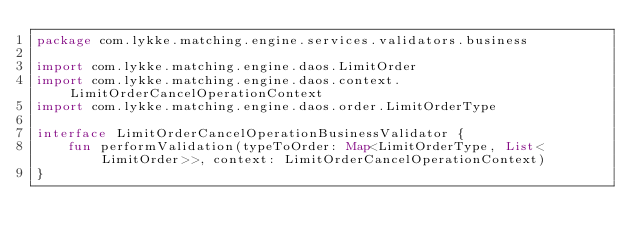<code> <loc_0><loc_0><loc_500><loc_500><_Kotlin_>package com.lykke.matching.engine.services.validators.business

import com.lykke.matching.engine.daos.LimitOrder
import com.lykke.matching.engine.daos.context.LimitOrderCancelOperationContext
import com.lykke.matching.engine.daos.order.LimitOrderType

interface LimitOrderCancelOperationBusinessValidator {
    fun performValidation(typeToOrder: Map<LimitOrderType, List<LimitOrder>>, context: LimitOrderCancelOperationContext)
}</code> 